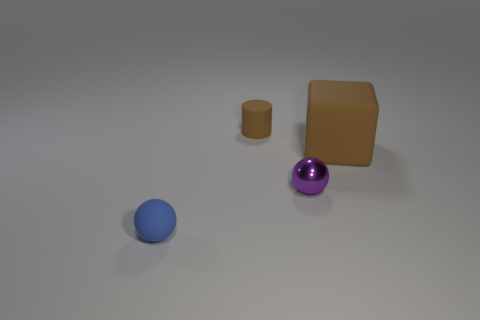Add 3 large red shiny things. How many objects exist? 7 Subtract 1 cubes. How many cubes are left? 0 Subtract all blocks. How many objects are left? 3 Subtract all blue matte things. Subtract all purple metallic balls. How many objects are left? 2 Add 4 brown cubes. How many brown cubes are left? 5 Add 2 large metallic things. How many large metallic things exist? 2 Subtract 0 green blocks. How many objects are left? 4 Subtract all gray cylinders. Subtract all purple balls. How many cylinders are left? 1 